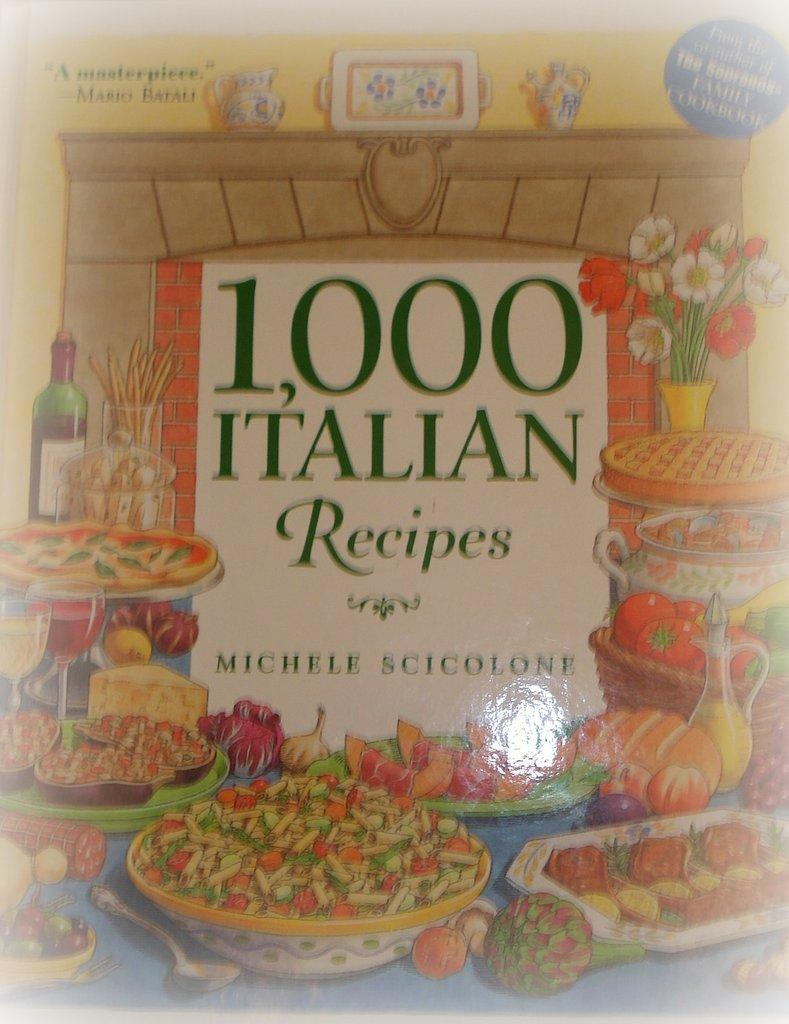<image>
Create a compact narrative representing the image presented. A cookbook by Michele Scicolone claims to have 1,000 Italian recipes in it. 